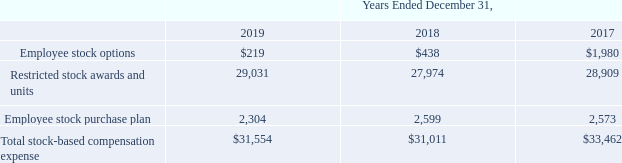Stock-based compensation expense categorized by various equity components for the years ended December 31, 2019, 2018 and 2017 is summarized in the table below (in thousands):
During the years ended December 31, 2019, 2018 and 2017, the Company granted stock options covering zero, zero and 70,000 shares, respectively. The 2017 estimated per share fair value of the grant was $4.62 before estimated forfeitures.
The total fair value of restricted stock awards and units vested during the years ended December 31, 2019, 2018 and 2017 was $30.1 million, $30.4 million and $22.7 million, respectively.
The total intrinsic value of options exercised during the years ended December 31, 2019, 2018 and 2017 was $0.2 million, $1.0 million and $5.5 million, respectively. The intrinsic value is calculated as the difference between the market value on the date of exercise and the exercise price of the shares.
As of December 31, 2019, the unrecognized stock-based compensation balance after estimated forfeitures consisted of $0.1 million related to unvested stock options, to be recognized over an estimated weighted average amortization period of 1.5 years, and $40.3 million related to restricted stock awards and units, including performance-based awards and units, to be recognized over an estimated weighted average amortization period of 2.3 years.
As of December 31, 2018, the unrecognized stock-based compensation balance after estimated forfeitures related to unvested stock options was $0.3 million to be recognized over an estimated weighted average amortization period of 2.0 years and $40.6 million related to restricted stock awards and units, including performance-based awards and units, to be recognized over an estimated weighted average amortization period of 2.2 years.
What is the estimated per share fair value of the granted stock options before estimated forfeitures in 2017? $4.62. What is the total fair value of restricted stock awards and units in 2018 and 2017, respectively?  $30.4 million, $22.7 million. How does the company calculate the intrinsic value? The difference between the market value on the date of exercise and the exercise price of the shares. What is the proportion of employee stock options and employee stock purchase plans over total stock-based compensation expense in 2018? (438+2,599)/31,011 
Answer: 0.1. What is the average total stock-based compensation expense for the last 3 years (2017 - 2019)?
Answer scale should be: thousand. (31,554+31,011+33,462)/3 
Answer: 32009. What is the percentage change in restricted stock awards and units’ expenses from 2018 to 2019?
Answer scale should be: percent. (29,031-27,974)/27,974 
Answer: 3.78. 